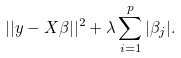<formula> <loc_0><loc_0><loc_500><loc_500>| | y - X \beta | | ^ { 2 } + \lambda \sum _ { i = 1 } ^ { p } | \beta _ { j } | .</formula> 